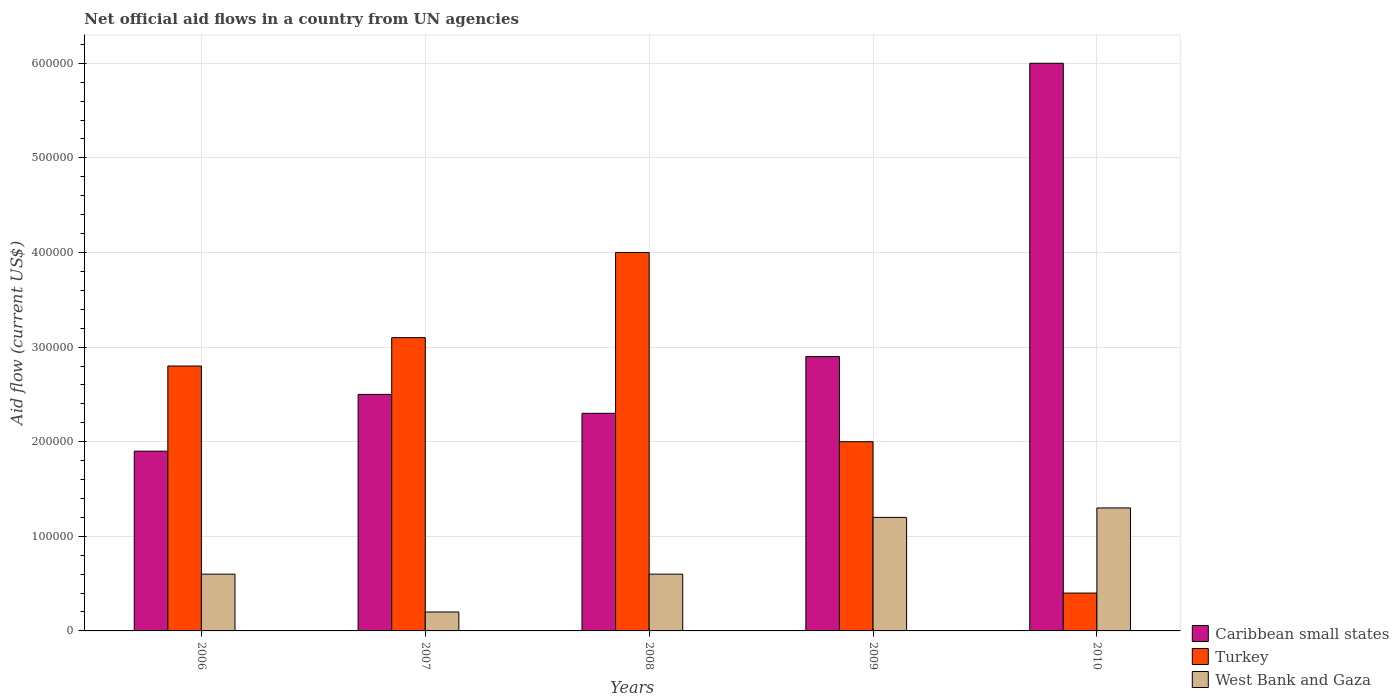How many groups of bars are there?
Make the answer very short. 5. Are the number of bars per tick equal to the number of legend labels?
Ensure brevity in your answer.  Yes. What is the label of the 1st group of bars from the left?
Offer a very short reply. 2006. In how many cases, is the number of bars for a given year not equal to the number of legend labels?
Offer a very short reply. 0. What is the net official aid flow in West Bank and Gaza in 2006?
Keep it short and to the point. 6.00e+04. Across all years, what is the maximum net official aid flow in Turkey?
Offer a very short reply. 4.00e+05. In which year was the net official aid flow in Caribbean small states maximum?
Make the answer very short. 2010. In which year was the net official aid flow in Turkey minimum?
Your answer should be very brief. 2010. What is the total net official aid flow in West Bank and Gaza in the graph?
Make the answer very short. 3.90e+05. What is the difference between the net official aid flow in Caribbean small states in 2006 and that in 2008?
Provide a short and direct response. -4.00e+04. What is the difference between the net official aid flow in Caribbean small states in 2008 and the net official aid flow in West Bank and Gaza in 2007?
Your response must be concise. 2.10e+05. What is the average net official aid flow in West Bank and Gaza per year?
Provide a succinct answer. 7.80e+04. In the year 2009, what is the difference between the net official aid flow in Caribbean small states and net official aid flow in West Bank and Gaza?
Keep it short and to the point. 1.70e+05. In how many years, is the net official aid flow in West Bank and Gaza greater than 280000 US$?
Ensure brevity in your answer.  0. What is the ratio of the net official aid flow in Turkey in 2007 to that in 2010?
Provide a short and direct response. 7.75. What is the difference between the highest and the lowest net official aid flow in Caribbean small states?
Provide a succinct answer. 4.10e+05. In how many years, is the net official aid flow in West Bank and Gaza greater than the average net official aid flow in West Bank and Gaza taken over all years?
Make the answer very short. 2. Is the sum of the net official aid flow in West Bank and Gaza in 2009 and 2010 greater than the maximum net official aid flow in Turkey across all years?
Provide a short and direct response. No. What does the 1st bar from the left in 2007 represents?
Offer a terse response. Caribbean small states. What does the 2nd bar from the right in 2006 represents?
Offer a terse response. Turkey. Is it the case that in every year, the sum of the net official aid flow in Turkey and net official aid flow in West Bank and Gaza is greater than the net official aid flow in Caribbean small states?
Offer a very short reply. No. How many years are there in the graph?
Make the answer very short. 5. Does the graph contain any zero values?
Offer a very short reply. No. Where does the legend appear in the graph?
Offer a very short reply. Bottom right. How are the legend labels stacked?
Your response must be concise. Vertical. What is the title of the graph?
Your answer should be compact. Net official aid flows in a country from UN agencies. What is the label or title of the Y-axis?
Offer a very short reply. Aid flow (current US$). What is the Aid flow (current US$) in Caribbean small states in 2006?
Provide a succinct answer. 1.90e+05. What is the Aid flow (current US$) in West Bank and Gaza in 2006?
Your response must be concise. 6.00e+04. What is the Aid flow (current US$) in Caribbean small states in 2007?
Provide a succinct answer. 2.50e+05. What is the Aid flow (current US$) of Turkey in 2008?
Ensure brevity in your answer.  4.00e+05. What is the Aid flow (current US$) in West Bank and Gaza in 2008?
Your answer should be very brief. 6.00e+04. What is the Aid flow (current US$) of Caribbean small states in 2009?
Your answer should be very brief. 2.90e+05. What is the Aid flow (current US$) in Turkey in 2009?
Your answer should be compact. 2.00e+05. What is the Aid flow (current US$) of West Bank and Gaza in 2009?
Give a very brief answer. 1.20e+05. What is the Aid flow (current US$) in Caribbean small states in 2010?
Offer a terse response. 6.00e+05. What is the Aid flow (current US$) in Turkey in 2010?
Your response must be concise. 4.00e+04. Across all years, what is the maximum Aid flow (current US$) in Caribbean small states?
Provide a succinct answer. 6.00e+05. Across all years, what is the maximum Aid flow (current US$) of Turkey?
Keep it short and to the point. 4.00e+05. Across all years, what is the minimum Aid flow (current US$) in Caribbean small states?
Your response must be concise. 1.90e+05. What is the total Aid flow (current US$) in Caribbean small states in the graph?
Your answer should be compact. 1.56e+06. What is the total Aid flow (current US$) of Turkey in the graph?
Your answer should be very brief. 1.23e+06. What is the total Aid flow (current US$) in West Bank and Gaza in the graph?
Give a very brief answer. 3.90e+05. What is the difference between the Aid flow (current US$) in Caribbean small states in 2006 and that in 2007?
Your response must be concise. -6.00e+04. What is the difference between the Aid flow (current US$) in Caribbean small states in 2006 and that in 2008?
Your answer should be very brief. -4.00e+04. What is the difference between the Aid flow (current US$) in Turkey in 2006 and that in 2008?
Your response must be concise. -1.20e+05. What is the difference between the Aid flow (current US$) of Caribbean small states in 2006 and that in 2009?
Ensure brevity in your answer.  -1.00e+05. What is the difference between the Aid flow (current US$) in West Bank and Gaza in 2006 and that in 2009?
Ensure brevity in your answer.  -6.00e+04. What is the difference between the Aid flow (current US$) of Caribbean small states in 2006 and that in 2010?
Provide a short and direct response. -4.10e+05. What is the difference between the Aid flow (current US$) in Turkey in 2006 and that in 2010?
Ensure brevity in your answer.  2.40e+05. What is the difference between the Aid flow (current US$) in West Bank and Gaza in 2006 and that in 2010?
Your answer should be very brief. -7.00e+04. What is the difference between the Aid flow (current US$) of Caribbean small states in 2007 and that in 2008?
Provide a short and direct response. 2.00e+04. What is the difference between the Aid flow (current US$) of Turkey in 2007 and that in 2008?
Your response must be concise. -9.00e+04. What is the difference between the Aid flow (current US$) of West Bank and Gaza in 2007 and that in 2008?
Your answer should be compact. -4.00e+04. What is the difference between the Aid flow (current US$) in Turkey in 2007 and that in 2009?
Ensure brevity in your answer.  1.10e+05. What is the difference between the Aid flow (current US$) in Caribbean small states in 2007 and that in 2010?
Your response must be concise. -3.50e+05. What is the difference between the Aid flow (current US$) in Turkey in 2007 and that in 2010?
Ensure brevity in your answer.  2.70e+05. What is the difference between the Aid flow (current US$) in West Bank and Gaza in 2007 and that in 2010?
Provide a short and direct response. -1.10e+05. What is the difference between the Aid flow (current US$) of Caribbean small states in 2008 and that in 2009?
Give a very brief answer. -6.00e+04. What is the difference between the Aid flow (current US$) in Turkey in 2008 and that in 2009?
Provide a short and direct response. 2.00e+05. What is the difference between the Aid flow (current US$) in Caribbean small states in 2008 and that in 2010?
Offer a terse response. -3.70e+05. What is the difference between the Aid flow (current US$) in Turkey in 2008 and that in 2010?
Keep it short and to the point. 3.60e+05. What is the difference between the Aid flow (current US$) of West Bank and Gaza in 2008 and that in 2010?
Provide a short and direct response. -7.00e+04. What is the difference between the Aid flow (current US$) in Caribbean small states in 2009 and that in 2010?
Offer a very short reply. -3.10e+05. What is the difference between the Aid flow (current US$) of Turkey in 2009 and that in 2010?
Keep it short and to the point. 1.60e+05. What is the difference between the Aid flow (current US$) of West Bank and Gaza in 2009 and that in 2010?
Your answer should be compact. -10000. What is the difference between the Aid flow (current US$) of Caribbean small states in 2006 and the Aid flow (current US$) of Turkey in 2007?
Offer a terse response. -1.20e+05. What is the difference between the Aid flow (current US$) of Caribbean small states in 2006 and the Aid flow (current US$) of West Bank and Gaza in 2008?
Make the answer very short. 1.30e+05. What is the difference between the Aid flow (current US$) of Caribbean small states in 2006 and the Aid flow (current US$) of Turkey in 2009?
Ensure brevity in your answer.  -10000. What is the difference between the Aid flow (current US$) of Caribbean small states in 2006 and the Aid flow (current US$) of West Bank and Gaza in 2009?
Offer a terse response. 7.00e+04. What is the difference between the Aid flow (current US$) of Caribbean small states in 2006 and the Aid flow (current US$) of West Bank and Gaza in 2010?
Your answer should be compact. 6.00e+04. What is the difference between the Aid flow (current US$) of Caribbean small states in 2007 and the Aid flow (current US$) of West Bank and Gaza in 2008?
Offer a terse response. 1.90e+05. What is the difference between the Aid flow (current US$) in Caribbean small states in 2007 and the Aid flow (current US$) in West Bank and Gaza in 2009?
Give a very brief answer. 1.30e+05. What is the difference between the Aid flow (current US$) in Caribbean small states in 2007 and the Aid flow (current US$) in Turkey in 2010?
Provide a short and direct response. 2.10e+05. What is the difference between the Aid flow (current US$) in Caribbean small states in 2008 and the Aid flow (current US$) in Turkey in 2009?
Your response must be concise. 3.00e+04. What is the difference between the Aid flow (current US$) in Caribbean small states in 2008 and the Aid flow (current US$) in West Bank and Gaza in 2010?
Your answer should be compact. 1.00e+05. What is the difference between the Aid flow (current US$) in Turkey in 2008 and the Aid flow (current US$) in West Bank and Gaza in 2010?
Your answer should be very brief. 2.70e+05. What is the difference between the Aid flow (current US$) of Caribbean small states in 2009 and the Aid flow (current US$) of West Bank and Gaza in 2010?
Your response must be concise. 1.60e+05. What is the average Aid flow (current US$) in Caribbean small states per year?
Your answer should be compact. 3.12e+05. What is the average Aid flow (current US$) of Turkey per year?
Your response must be concise. 2.46e+05. What is the average Aid flow (current US$) in West Bank and Gaza per year?
Offer a very short reply. 7.80e+04. In the year 2006, what is the difference between the Aid flow (current US$) in Caribbean small states and Aid flow (current US$) in West Bank and Gaza?
Offer a very short reply. 1.30e+05. In the year 2007, what is the difference between the Aid flow (current US$) in Caribbean small states and Aid flow (current US$) in Turkey?
Offer a terse response. -6.00e+04. In the year 2008, what is the difference between the Aid flow (current US$) in Caribbean small states and Aid flow (current US$) in Turkey?
Make the answer very short. -1.70e+05. In the year 2008, what is the difference between the Aid flow (current US$) of Caribbean small states and Aid flow (current US$) of West Bank and Gaza?
Make the answer very short. 1.70e+05. In the year 2009, what is the difference between the Aid flow (current US$) in Caribbean small states and Aid flow (current US$) in Turkey?
Give a very brief answer. 9.00e+04. In the year 2009, what is the difference between the Aid flow (current US$) of Caribbean small states and Aid flow (current US$) of West Bank and Gaza?
Ensure brevity in your answer.  1.70e+05. In the year 2010, what is the difference between the Aid flow (current US$) of Caribbean small states and Aid flow (current US$) of Turkey?
Your answer should be very brief. 5.60e+05. In the year 2010, what is the difference between the Aid flow (current US$) in Turkey and Aid flow (current US$) in West Bank and Gaza?
Offer a very short reply. -9.00e+04. What is the ratio of the Aid flow (current US$) in Caribbean small states in 2006 to that in 2007?
Provide a succinct answer. 0.76. What is the ratio of the Aid flow (current US$) of Turkey in 2006 to that in 2007?
Your answer should be very brief. 0.9. What is the ratio of the Aid flow (current US$) of Caribbean small states in 2006 to that in 2008?
Ensure brevity in your answer.  0.83. What is the ratio of the Aid flow (current US$) in West Bank and Gaza in 2006 to that in 2008?
Ensure brevity in your answer.  1. What is the ratio of the Aid flow (current US$) of Caribbean small states in 2006 to that in 2009?
Keep it short and to the point. 0.66. What is the ratio of the Aid flow (current US$) in Turkey in 2006 to that in 2009?
Your response must be concise. 1.4. What is the ratio of the Aid flow (current US$) of Caribbean small states in 2006 to that in 2010?
Provide a short and direct response. 0.32. What is the ratio of the Aid flow (current US$) in Turkey in 2006 to that in 2010?
Ensure brevity in your answer.  7. What is the ratio of the Aid flow (current US$) in West Bank and Gaza in 2006 to that in 2010?
Your answer should be very brief. 0.46. What is the ratio of the Aid flow (current US$) of Caribbean small states in 2007 to that in 2008?
Offer a very short reply. 1.09. What is the ratio of the Aid flow (current US$) of Turkey in 2007 to that in 2008?
Offer a terse response. 0.78. What is the ratio of the Aid flow (current US$) in West Bank and Gaza in 2007 to that in 2008?
Your answer should be very brief. 0.33. What is the ratio of the Aid flow (current US$) of Caribbean small states in 2007 to that in 2009?
Your answer should be compact. 0.86. What is the ratio of the Aid flow (current US$) of Turkey in 2007 to that in 2009?
Your response must be concise. 1.55. What is the ratio of the Aid flow (current US$) of West Bank and Gaza in 2007 to that in 2009?
Your response must be concise. 0.17. What is the ratio of the Aid flow (current US$) in Caribbean small states in 2007 to that in 2010?
Keep it short and to the point. 0.42. What is the ratio of the Aid flow (current US$) of Turkey in 2007 to that in 2010?
Provide a succinct answer. 7.75. What is the ratio of the Aid flow (current US$) in West Bank and Gaza in 2007 to that in 2010?
Your answer should be very brief. 0.15. What is the ratio of the Aid flow (current US$) in Caribbean small states in 2008 to that in 2009?
Your answer should be compact. 0.79. What is the ratio of the Aid flow (current US$) of West Bank and Gaza in 2008 to that in 2009?
Ensure brevity in your answer.  0.5. What is the ratio of the Aid flow (current US$) of Caribbean small states in 2008 to that in 2010?
Give a very brief answer. 0.38. What is the ratio of the Aid flow (current US$) in West Bank and Gaza in 2008 to that in 2010?
Give a very brief answer. 0.46. What is the ratio of the Aid flow (current US$) of Caribbean small states in 2009 to that in 2010?
Make the answer very short. 0.48. What is the difference between the highest and the second highest Aid flow (current US$) in Caribbean small states?
Offer a terse response. 3.10e+05. What is the difference between the highest and the second highest Aid flow (current US$) in Turkey?
Your answer should be compact. 9.00e+04. What is the difference between the highest and the second highest Aid flow (current US$) in West Bank and Gaza?
Your answer should be compact. 10000. What is the difference between the highest and the lowest Aid flow (current US$) in Turkey?
Provide a short and direct response. 3.60e+05. 